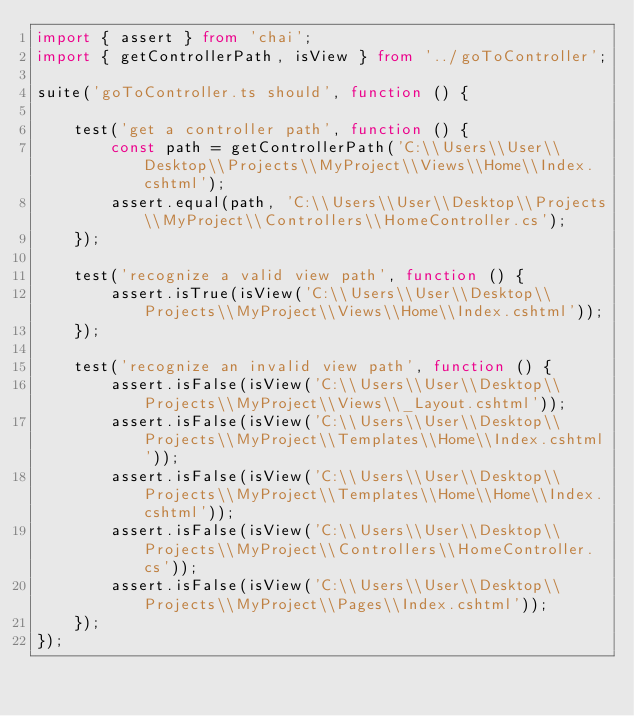<code> <loc_0><loc_0><loc_500><loc_500><_TypeScript_>import { assert } from 'chai';
import { getControllerPath, isView } from '../goToController';

suite('goToController.ts should', function () {

    test('get a controller path', function () {
        const path = getControllerPath('C:\\Users\\User\\Desktop\\Projects\\MyProject\\Views\\Home\\Index.cshtml');
        assert.equal(path, 'C:\\Users\\User\\Desktop\\Projects\\MyProject\\Controllers\\HomeController.cs');
    });

    test('recognize a valid view path', function () {
        assert.isTrue(isView('C:\\Users\\User\\Desktop\\Projects\\MyProject\\Views\\Home\\Index.cshtml'));
    });

    test('recognize an invalid view path', function () {
        assert.isFalse(isView('C:\\Users\\User\\Desktop\\Projects\\MyProject\\Views\\_Layout.cshtml'));
        assert.isFalse(isView('C:\\Users\\User\\Desktop\\Projects\\MyProject\\Templates\\Home\\Index.cshtml'));
        assert.isFalse(isView('C:\\Users\\User\\Desktop\\Projects\\MyProject\\Templates\\Home\\Home\\Index.cshtml'));
        assert.isFalse(isView('C:\\Users\\User\\Desktop\\Projects\\MyProject\\Controllers\\HomeController.cs'));
        assert.isFalse(isView('C:\\Users\\User\\Desktop\\Projects\\MyProject\\Pages\\Index.cshtml'));
    });
});</code> 